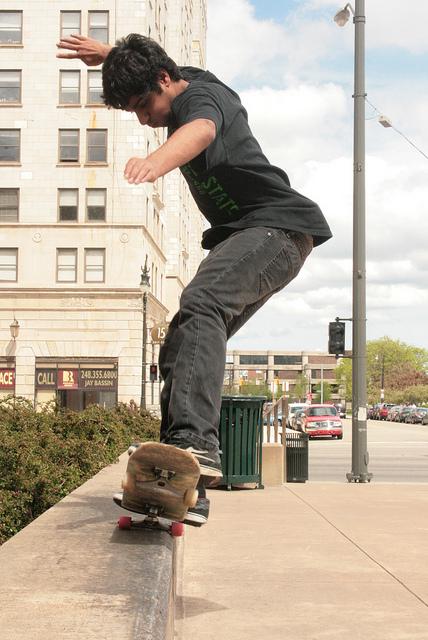Is this guy competing in a sport?
Be succinct. No. At what height is the traffic light?
Quick response, please. 7 feet. What is the guy doing?
Answer briefly. Skateboarding. 